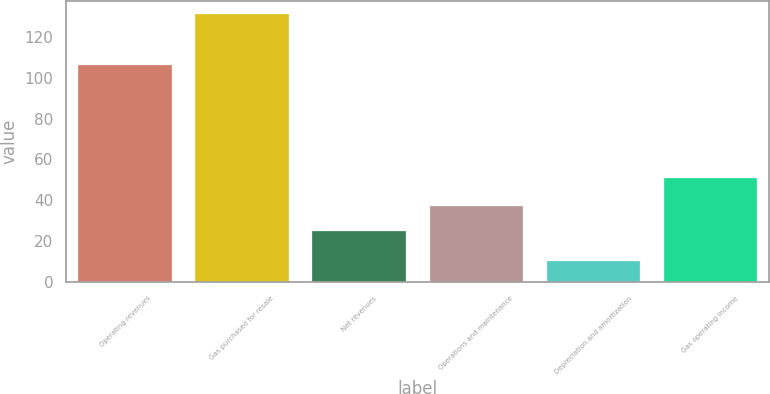Convert chart. <chart><loc_0><loc_0><loc_500><loc_500><bar_chart><fcel>Operating revenues<fcel>Gas purchased for resale<fcel>Net revenues<fcel>Operations and maintenance<fcel>Depreciation and amortization<fcel>Gas operating income<nl><fcel>106<fcel>131<fcel>25<fcel>37.1<fcel>10<fcel>51<nl></chart> 